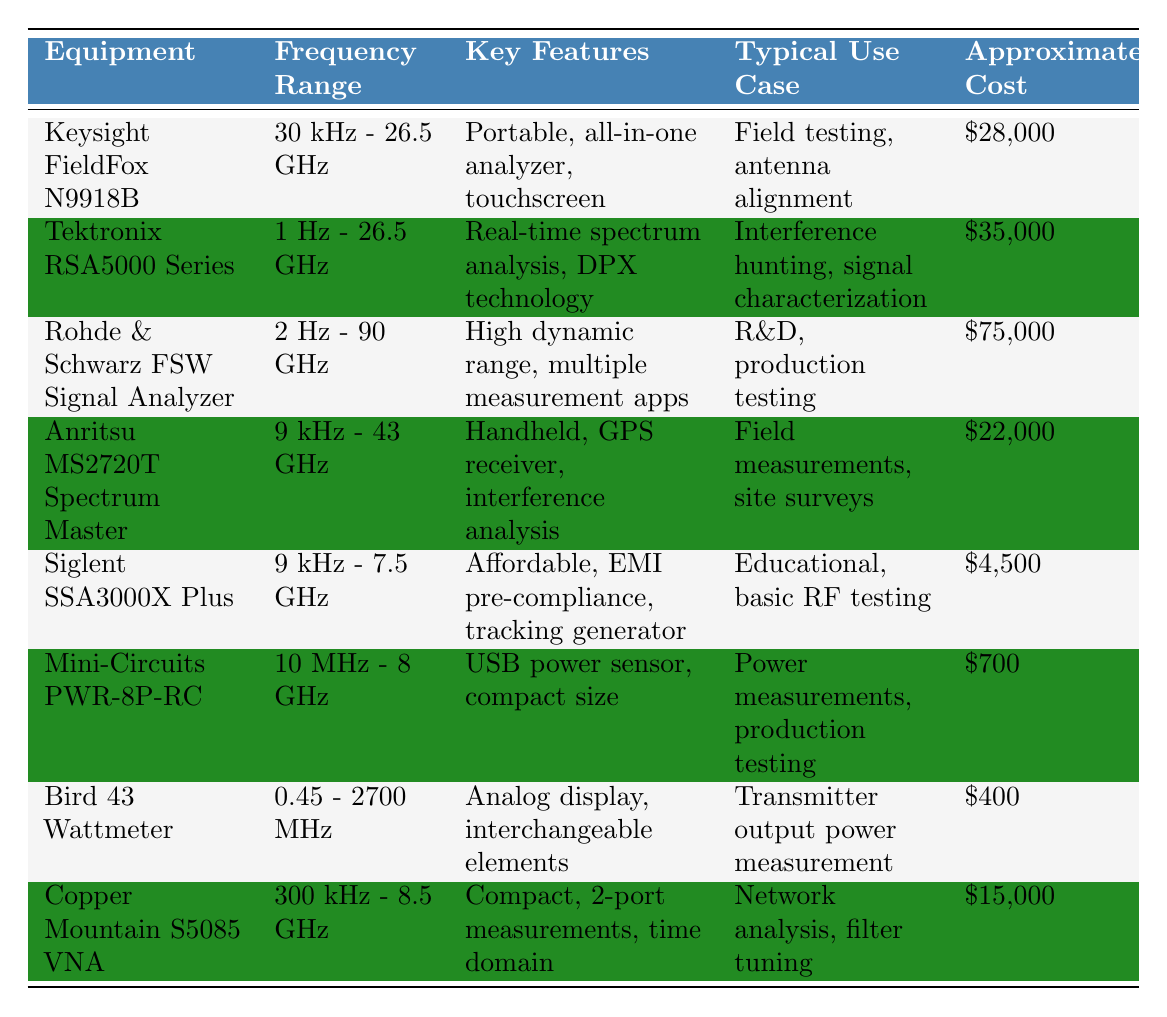What is the frequency range of the Rohde & Schwarz FSW Signal Analyzer? The table lists the equipment and their frequency ranges. For the Rohde & Schwarz FSW Signal Analyzer, the frequency range is specified as 2 Hz - 90 GHz.
Answer: 2 Hz - 90 GHz Which equipment has the lowest approximate cost? By reviewing the "Approximate Cost" column, the lowest cost item is Mini-Circuits PWR-8P-RC at $700.
Answer: $700 How much does the Tektronix RSA5000 Series cost? The cost listed for the Tektronix RSA5000 Series in the "Approximate Cost" column is $35,000.
Answer: $35,000 Is the Siglent SSA3000X Plus suitable for field testing? The "Typical Use Case" for Siglent SSA3000X Plus shows it is used for educational and basic RF testing, but does not indicate suitability for field testing specifically.
Answer: No What is the cost difference between the Keysight FieldFox N9918B and the Anritsu MS2720T Spectrum Master? The approximate cost of the Keysight FieldFox N9918B is $28,000 and the Anritsu MS2720T Spectrum Master is $22,000. The difference is $28,000 - $22,000 = $6,000.
Answer: $6,000 Which equipment is used for interference hunting? From the "Typical Use Case" column, the Tektronix RSA5000 Series is specified for interference hunting.
Answer: Tektronix RSA5000 Series If I have a budget of $5,000, which RF equipment can I purchase? Checking the "Approximate Cost" column shows that the Siglent SSA3000X Plus ($4,500) and the Mini-Circuits PWR-8P-RC ($700) can be purchased within a $5,000 budget.
Answer: Siglent SSA3000X Plus and Mini-Circuits PWR-8P-RC Which equipment has real-time spectrum analysis capabilities? The table shows that the Tektronix RSA5000 Series has real-time spectrum analysis as one of its key features.
Answer: Tektronix RSA5000 Series What is the maximum frequency range available among the listed equipment? The Rohde & Schwarz FSW Signal Analyzer has the highest frequency range of 2 Hz - 90 GHz listed in the table.
Answer: 2 Hz - 90 GHz If you want to perform power measurements, which tool would be appropriate? The table indicates that the Mini-Circuits PWR-8P-RC is specifically intended for power measurements.
Answer: Mini-Circuits PWR-8P-RC 